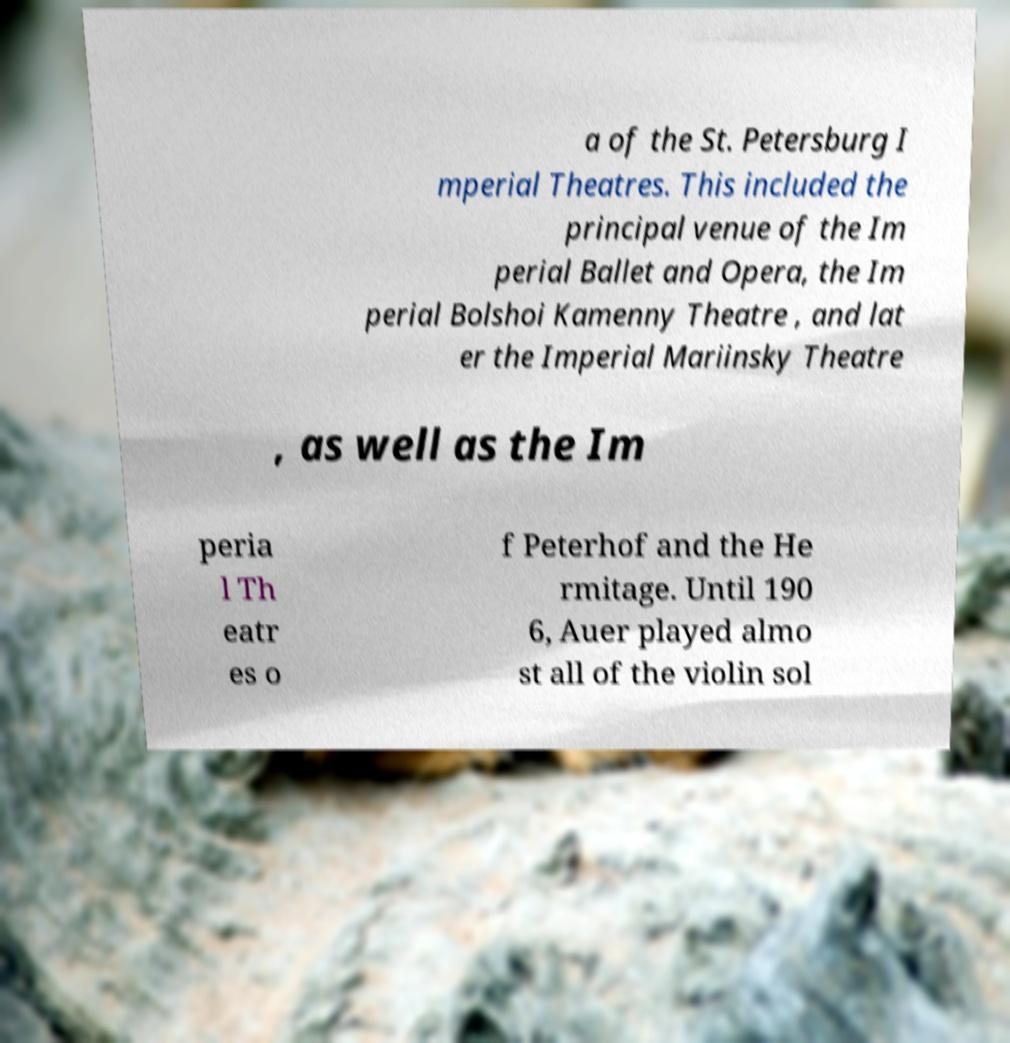Could you assist in decoding the text presented in this image and type it out clearly? a of the St. Petersburg I mperial Theatres. This included the principal venue of the Im perial Ballet and Opera, the Im perial Bolshoi Kamenny Theatre , and lat er the Imperial Mariinsky Theatre , as well as the Im peria l Th eatr es o f Peterhof and the He rmitage. Until 190 6, Auer played almo st all of the violin sol 